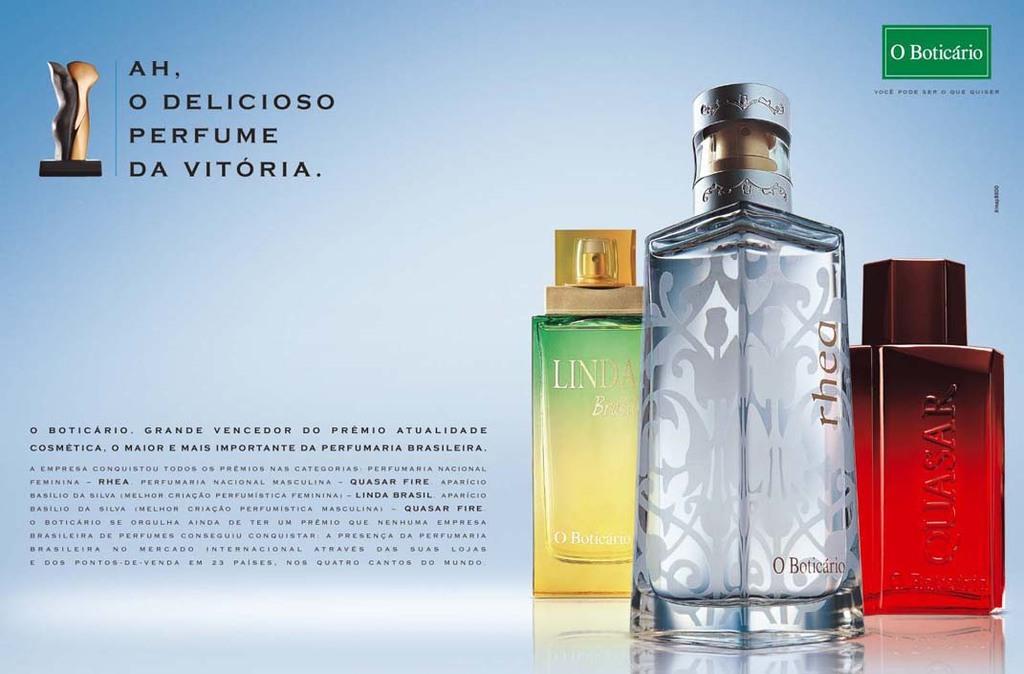What brand is the red bottle?
Give a very brief answer. Quasar. 